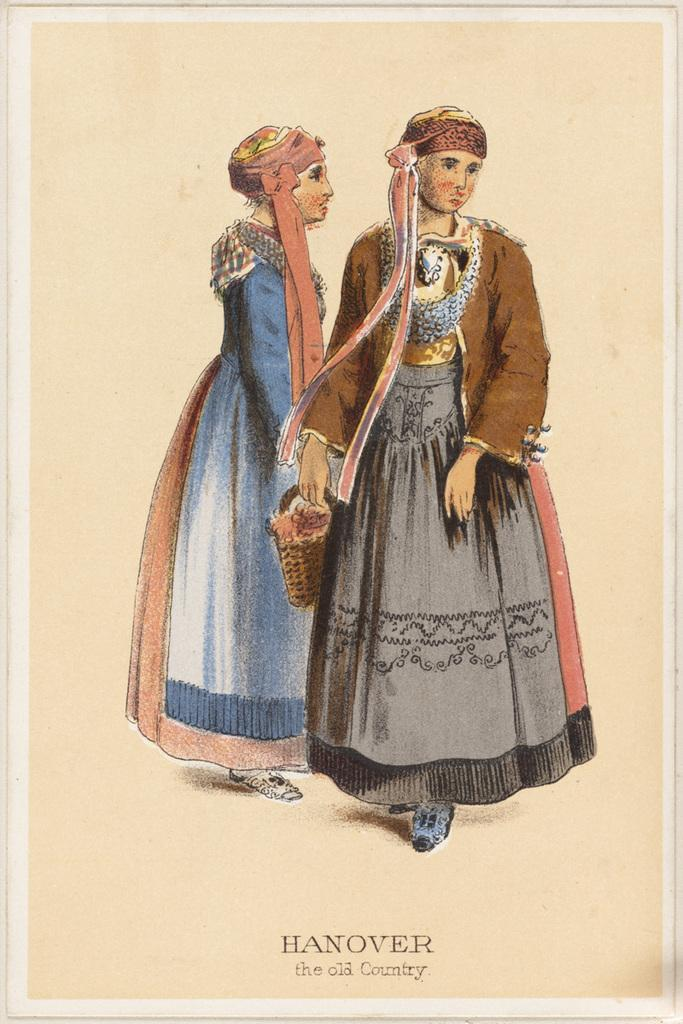What is the main object in the image? There is a poster in the image. What is depicted in the drawing on the poster? The drawing on the poster contains a drawing of multiple persons. What else can be found on the poster besides the drawing? There is text on the poster. What type of poison is mentioned in the text on the poster? There is no mention of poison in the text on the poster. What is the aftermath of the event depicted in the drawing on the poster? The image does not depict an event, so there is no aftermath to describe. 